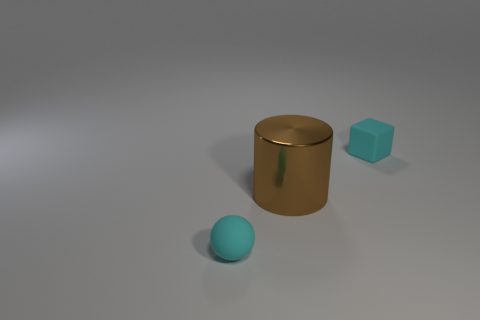There is a thing that is the same color as the tiny matte sphere; what shape is it?
Keep it short and to the point. Cube. Are there any other things that have the same material as the brown thing?
Provide a short and direct response. No. Are there fewer tiny rubber blocks than cyan metal cylinders?
Keep it short and to the point. No. Are there any other things of the same color as the big metallic cylinder?
Give a very brief answer. No. There is a matte thing that is left of the big brown metallic object; what shape is it?
Make the answer very short. Sphere. There is a small sphere; does it have the same color as the shiny cylinder that is on the right side of the tiny cyan matte ball?
Your response must be concise. No. Are there the same number of things that are behind the small cyan cube and cyan matte blocks that are behind the big brown object?
Offer a very short reply. No. How many other objects are the same size as the brown metal object?
Make the answer very short. 0. How big is the brown cylinder?
Your response must be concise. Large. Is the material of the small cyan cube the same as the sphere in front of the big metallic thing?
Provide a succinct answer. Yes. 